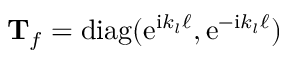<formula> <loc_0><loc_0><loc_500><loc_500>\mathbf T _ { f } = d i a g ( e ^ { i k _ { l } \ell } , e ^ { - i k _ { l } \ell } )</formula> 